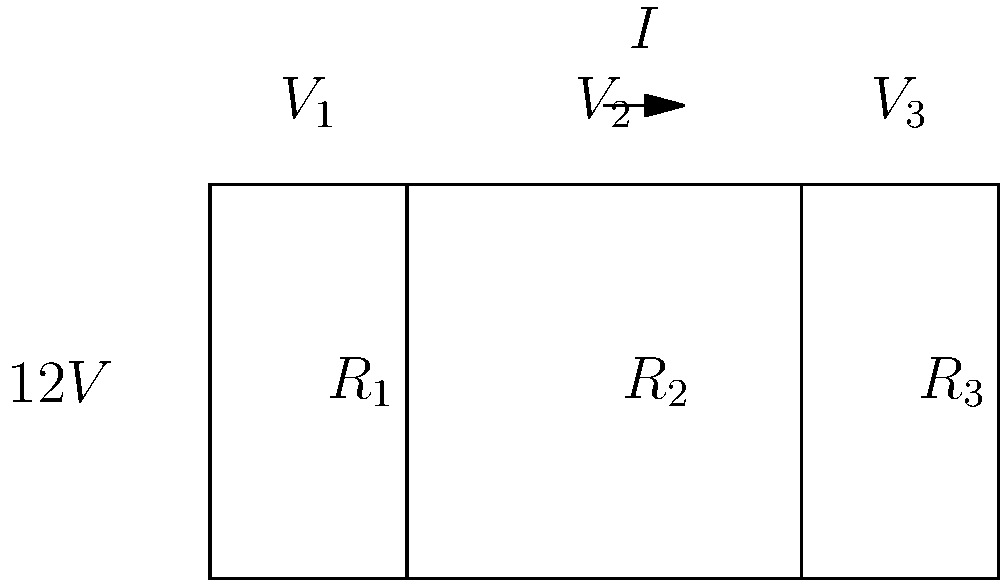In this series circuit, the voltage source is 12V, and the resistors have the following values: $R_1 = 2\Omega$, $R_2 = 3\Omega$, and $R_3 = 1\Omega$. Calculate the voltage drop across $R_2$.

To add a Shakespearean twist, imagine these resistors as characters in a play, each with their own "resistance" to the flow of the plot. How does $R_2$'s "voltage drop" contribute to the overall "dramatic tension" of the circuit? Let's approach this step-by-step, like unraveling the plot of a Shakespearean play:

1) First, we need to find the total resistance of the circuit:
   $R_{total} = R_1 + R_2 + R_3 = 2\Omega + 3\Omega + 1\Omega = 6\Omega$

2) Now, we can calculate the current flowing through the circuit using Ohm's Law:
   $I = \frac{V}{R_{total}} = \frac{12V}{6\Omega} = 2A$

3) The voltage drop across each resistor is proportional to its resistance. We can use Ohm's Law again to find the voltage drop across $R_2$:
   $V_2 = I \times R_2 = 2A \times 3\Omega = 6V$

Just as in a play where each character's actions contribute to the overall plot, each resistor's voltage drop contributes to the total voltage. $R_2$, with the largest resistance, has the largest "role" in this circuit's "drama," taking up half of the total voltage drop.
Answer: $6V$ 